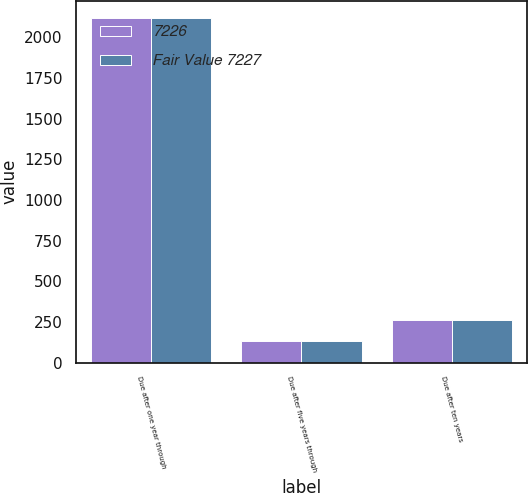Convert chart to OTSL. <chart><loc_0><loc_0><loc_500><loc_500><stacked_bar_chart><ecel><fcel>Due after one year through<fcel>Due after five years through<fcel>Due after ten years<nl><fcel>7226<fcel>2115<fcel>133<fcel>261<nl><fcel>Fair Value 7227<fcel>2118<fcel>132<fcel>259<nl></chart> 